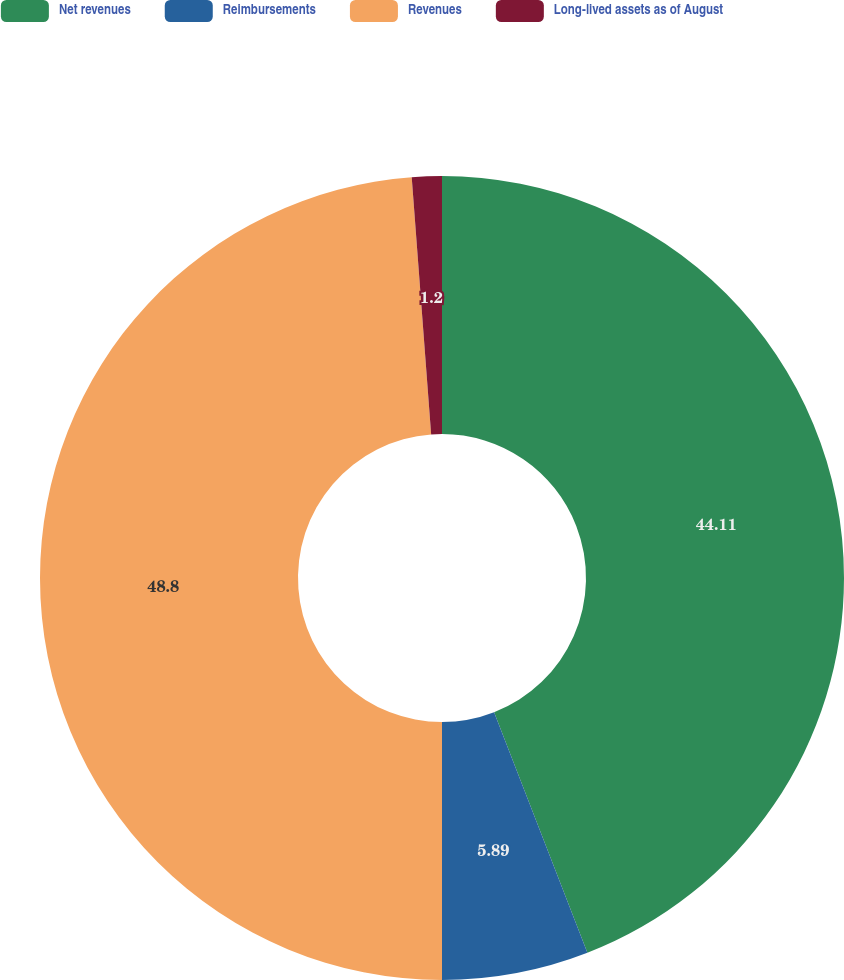Convert chart to OTSL. <chart><loc_0><loc_0><loc_500><loc_500><pie_chart><fcel>Net revenues<fcel>Reimbursements<fcel>Revenues<fcel>Long-lived assets as of August<nl><fcel>44.11%<fcel>5.89%<fcel>48.8%<fcel>1.2%<nl></chart> 